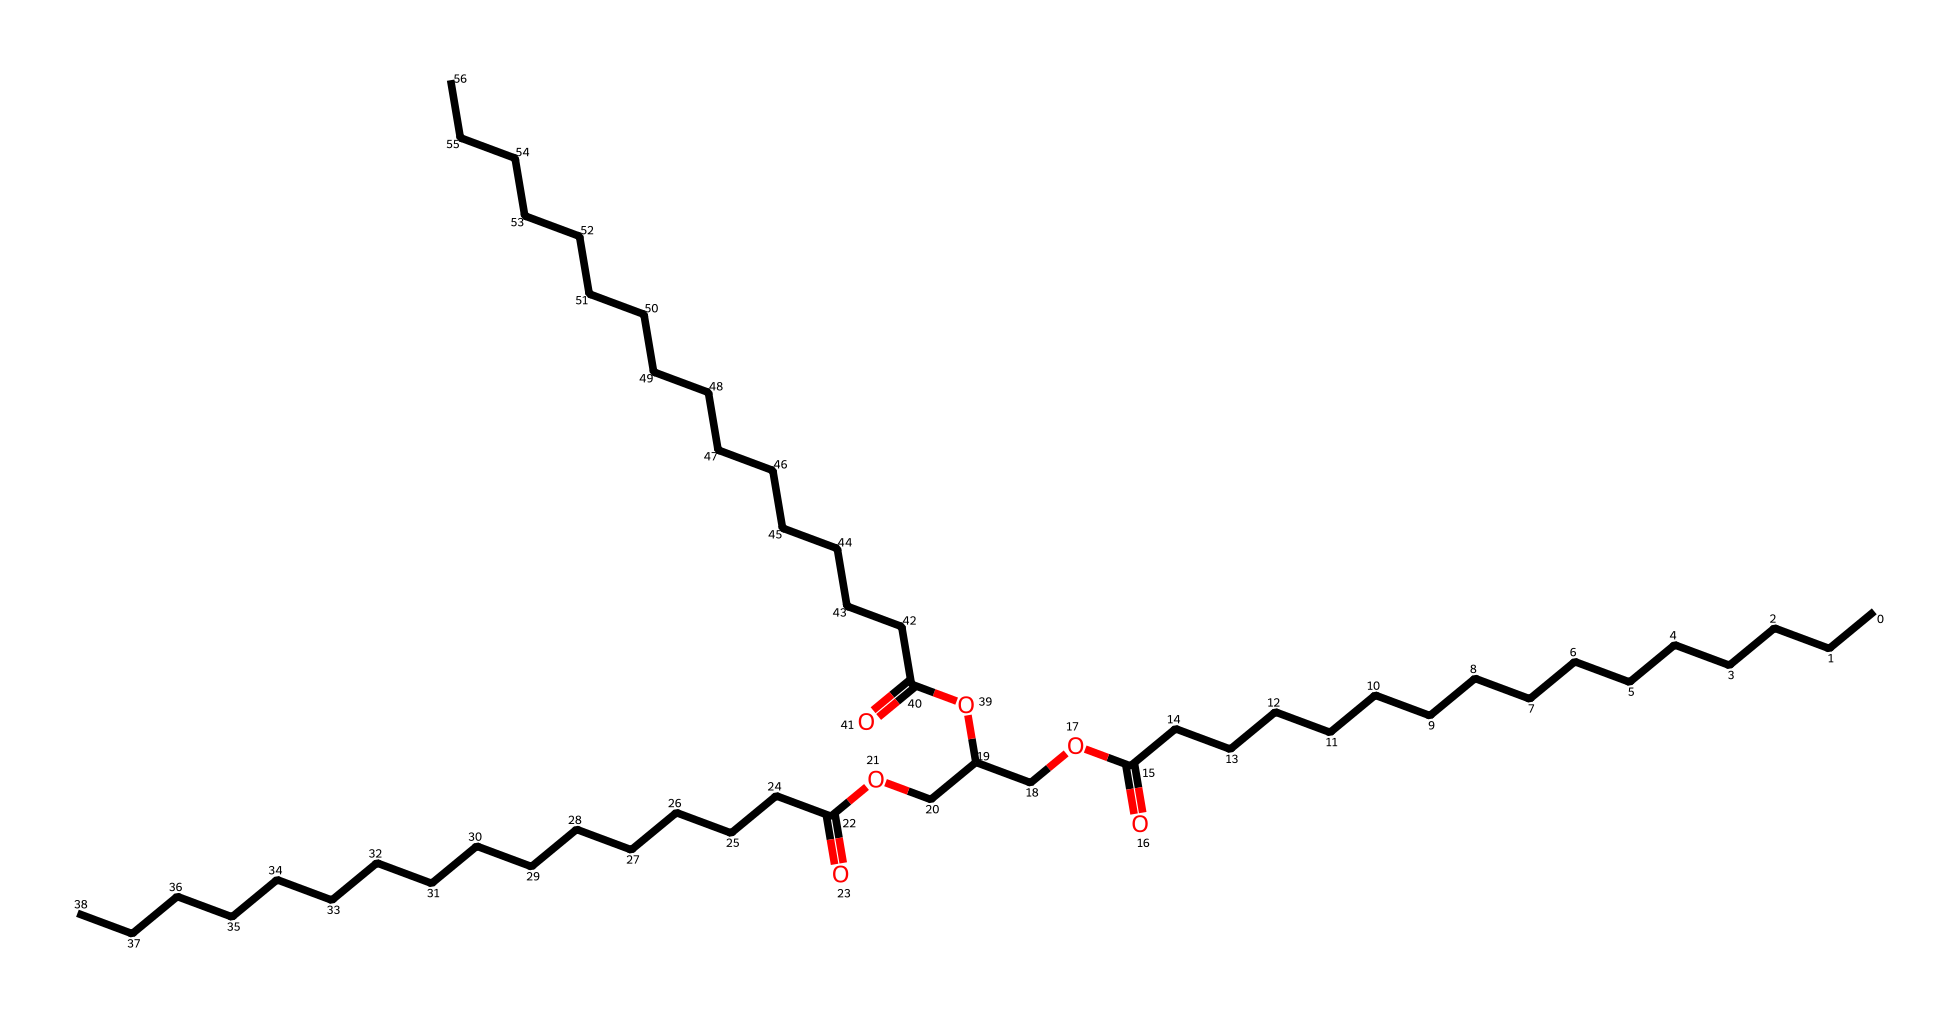What is the molecular formula of this chemical? To find the molecular formula, we count the different types of atoms present in the SMILES representation. In the given chemical, it contains a total of 39 carbon atoms, 74 hydrogen atoms, and 6 oxygen atoms, leading to the formula C39H74O6.
Answer: C39H74O6 How many carbon atoms are in this structure? The structure reveals the number of carbon (C) atoms that can be counted directly from the SMILES string. There are 39 instances of carbon, indicated by the presence of C's throughout the chemical description.
Answer: 39 What functional groups are present in this chemical? By analyzing the SMILES representation, we identify the functional groups based on common patterns. The presence of -COOH indicates carboxylic acids, and the -O- and -C(=O)- arrangements signify esters, which are typical in emulsifiers.
Answer: carboxylic acids and esters How many ester bonds are present? We identify ester bonds by looking for the -C(=O)O- sequences in the SMILES. In this representation, there are three instances of this configuration, indicating the presence of three ester bonds.
Answer: 3 Is this chemical likely to be hydrophobic or hydrophilic? Considering the structure, the long carbon chains suggest hydrophobic characteristics, while the carboxylic acids render it partially hydrophilic. However, overall, this chemical leans towards being hydrophobic due to the dominance of the carbon chains.
Answer: hydrophobic What is the primary role of emulsifiers like this in cake mixes? Emulsifiers facilitate the mixing of fats and water, helping to stabilize emulsions and improve texture. The presence of ester bonds and long hydrophobic carbon chains supports the notion that this chemical acts to create a stable emulsion in the cake mix, enhancing moisture and texture.
Answer: stabilize emulsions 